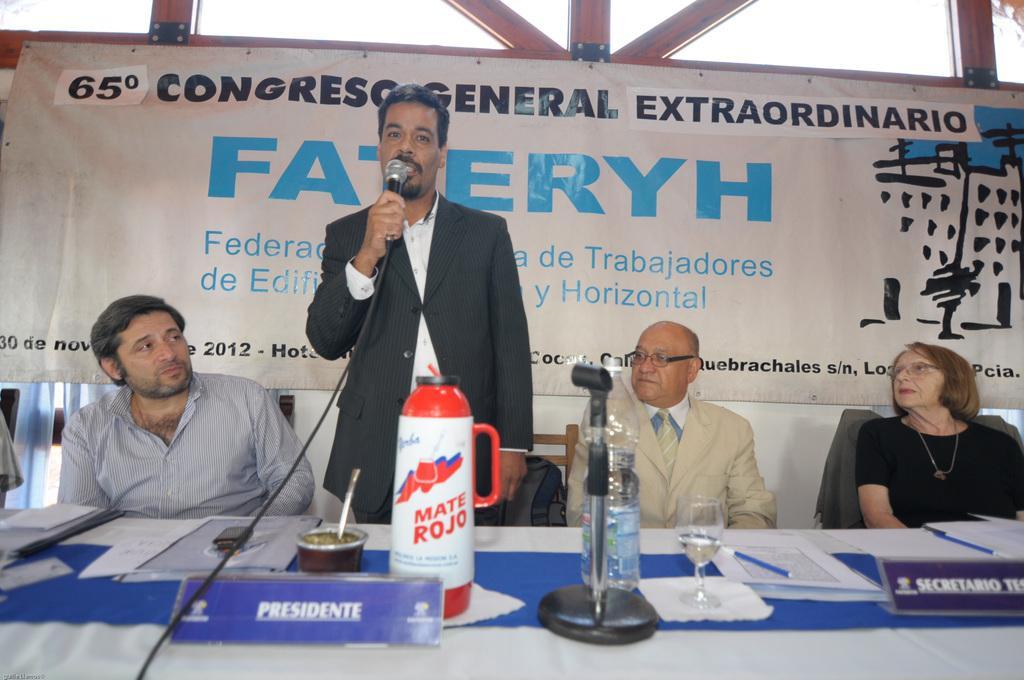Please provide a concise description of this image. At the bottom of the image there is a table with bottles, mic stand, glass with water, name boards, tissues, papers, pens and some other things. Behind the table there are three persons sitting. There is a man standing and holding a mic in his hand. Behind them there is a poster with something written on it. 